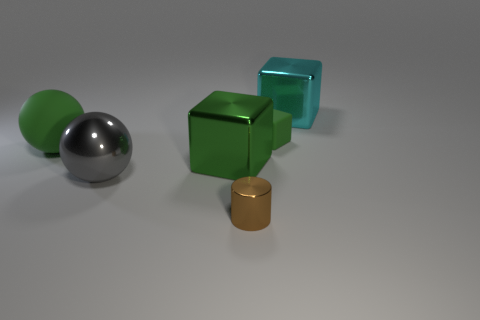Is the number of big green objects that are in front of the matte sphere less than the number of shiny objects?
Ensure brevity in your answer.  Yes. Do the small thing to the right of the tiny cylinder and the large green sphere have the same material?
Make the answer very short. Yes. There is a large ball that is the same material as the big cyan cube; what color is it?
Make the answer very short. Gray. Are there fewer small cylinders to the right of the cyan cube than large spheres to the left of the gray object?
Provide a succinct answer. Yes. Do the large ball that is on the left side of the gray thing and the small rubber block behind the big green metallic cube have the same color?
Offer a very short reply. Yes. Is there a big green ball made of the same material as the tiny green object?
Keep it short and to the point. Yes. There is a metallic block right of the large cube that is in front of the large cyan thing; what is its size?
Your answer should be very brief. Large. Are there more cubes than cylinders?
Make the answer very short. Yes. There is a green object on the right side of the green metal cube; is its size the same as the tiny metallic cylinder?
Keep it short and to the point. Yes. What number of cylinders have the same color as the large metal ball?
Your response must be concise. 0. 